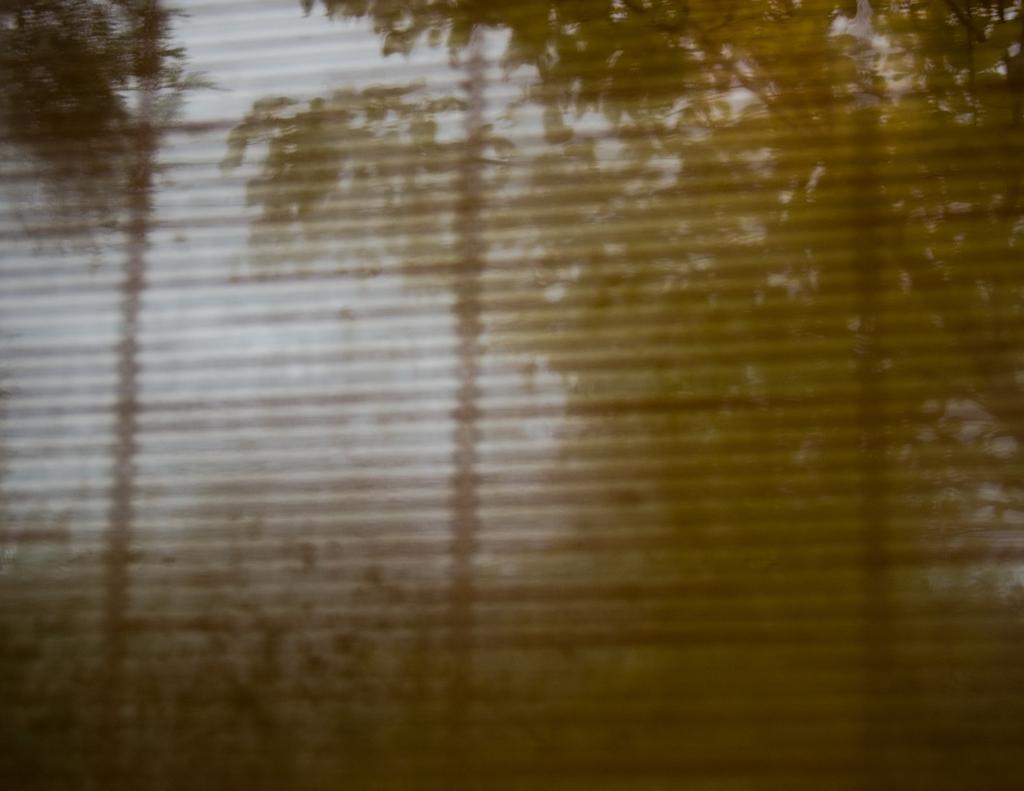Could you give a brief overview of what you see in this image? In the picture we can see a window cover from it we can see trees and sky. 